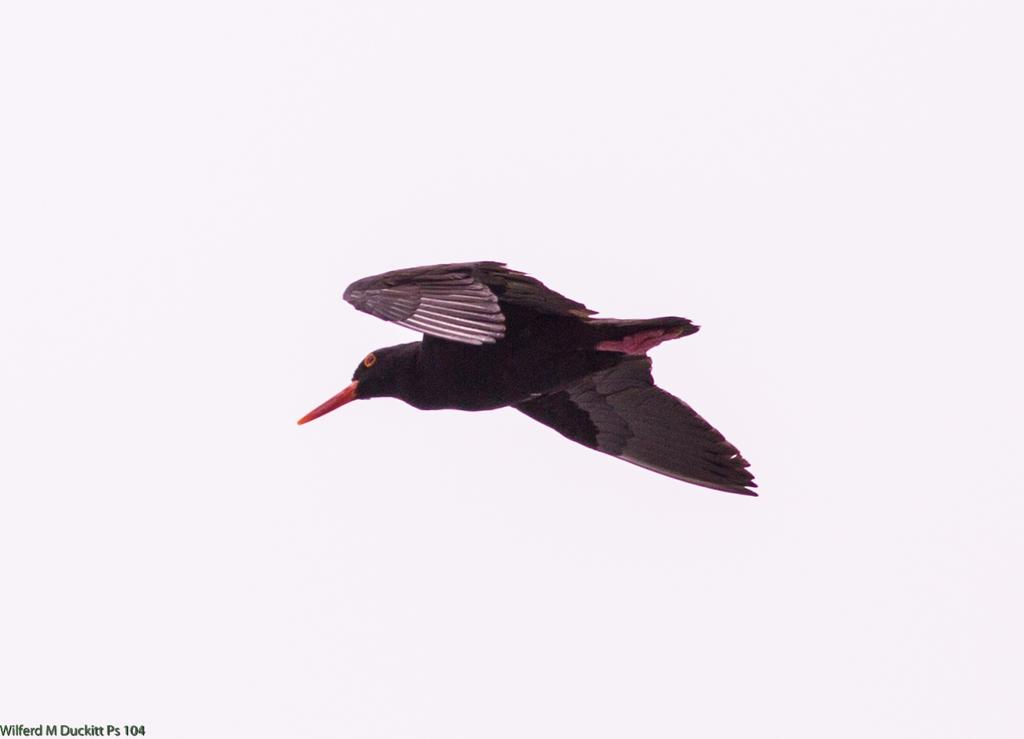What is the main subject of the image? There is a bird flying in the image. What color is the background of the image? The background of the image is white. Can you describe any additional features of the image? There is a watermark on the image. What is the bird's opinion on the increase in the number of trees in the area? The image does not provide any information about the bird's opinion or the number of trees in the area. 